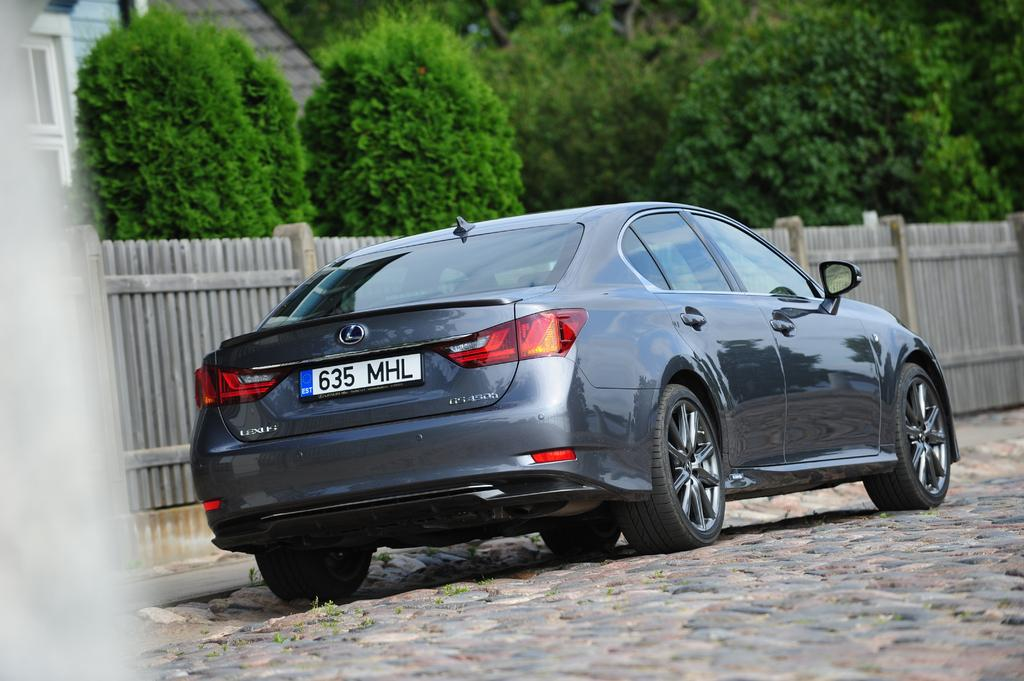What is the main subject of the image? The main subject of the image is a car. Can you describe the car in the image? The car has a number plate and is parked on the ground. What can be seen in the background of the image? In the background, there is a fence, a group of trees, and a building with windows and a roof. What type of lace can be seen hanging from the car's windows in the image? There is no lace hanging from the car's windows in the image. Can you describe the attack that is happening in the image? There is no attack happening in the image; it features a parked car and a background with a fence, trees, and a building. 